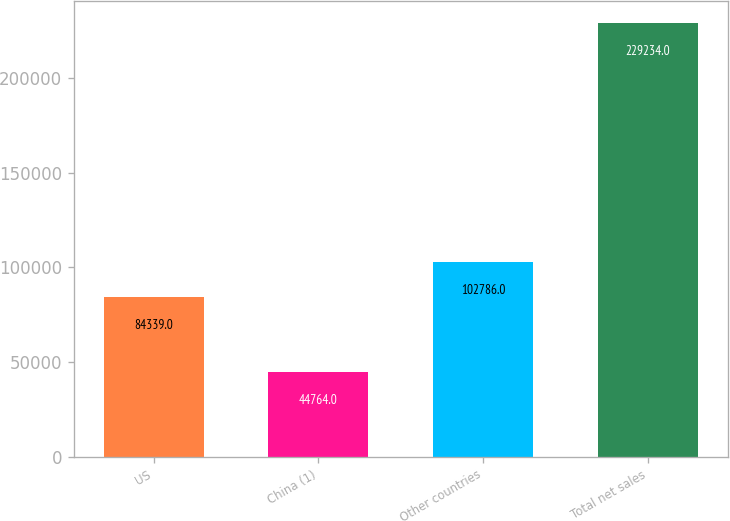Convert chart to OTSL. <chart><loc_0><loc_0><loc_500><loc_500><bar_chart><fcel>US<fcel>China (1)<fcel>Other countries<fcel>Total net sales<nl><fcel>84339<fcel>44764<fcel>102786<fcel>229234<nl></chart> 